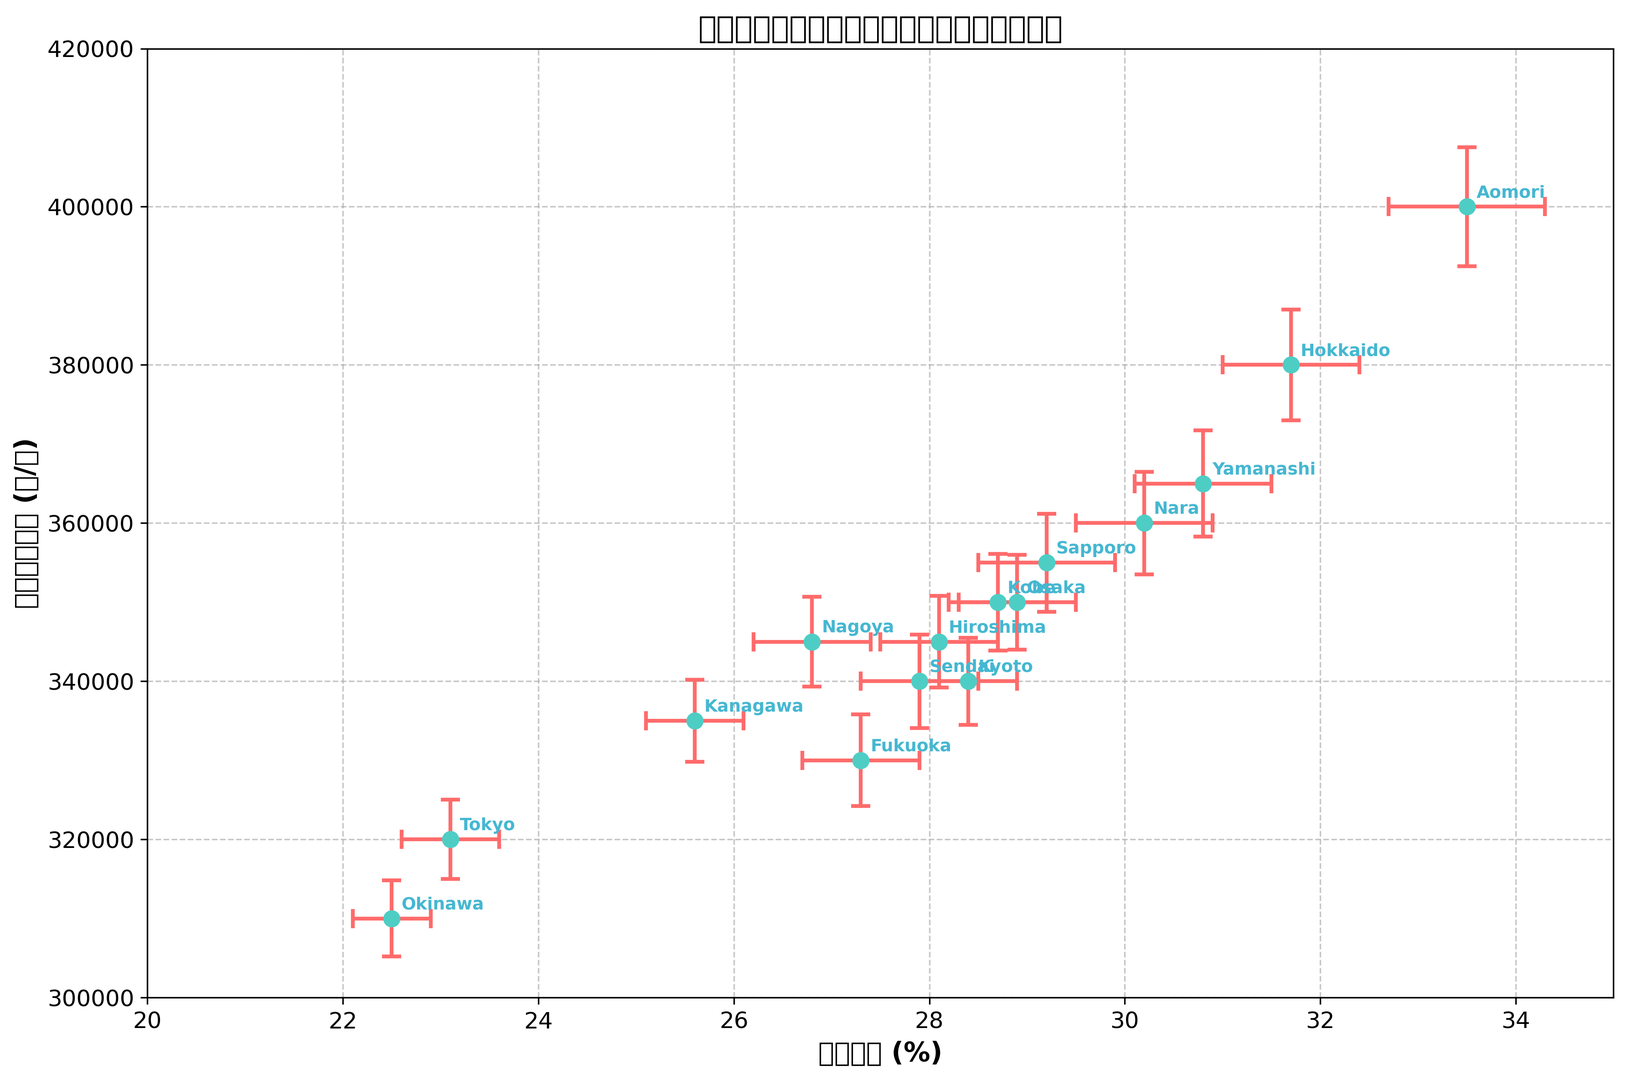Which region has the highest elderly population percentage? By looking at the plotted values of elderly population percentages, the highest value is at Aomori, reaching 33.5%.
Answer: Aomori What is the difference in elderly population percentage between Tokyo and Hokkaido? Tokyo has an elderly population percentage of 23.1%, while Hokkaido has 31.7%. The difference is 31.7% - 23.1% = 8.6%.
Answer: 8.6% Which region has the least welfare expenditure per capita? By checking the y-values of welfare expenditures, the smallest value belongs to Okinawa with 310,000 yen per capita.
Answer: Okinawa How does the welfare expenditure of Tokyo compare with Fukuoka? Tokyo has a welfare expenditure per capita of 320,000 yen, whereas Fukuoka has 330,000 yen. Fukuoka's expenditure is higher.
Answer: Fukuoka has higher expenditure What is the average welfare expenditure per capita of Sendai, Kobe, and Hiroshima? Adding the per capita expenditures: 340,000 (Sendai) + 350,000 (Kobe) + 345,000 (Hiroshima) and dividing by 3: (340,000 + 350,000 + 345,000) / 3 = 345,000 yen.
Answer: 345,000 yen Which region has the greatest margin of error in welfare expenditure, and what is its value? Reviewing the error bars, Aomori has the largest welfare expenditure error value of 7,500 yen.
Answer: Aomori, 7,500 yen Is there a region where the elderly population percentage and welfare expenditure per capita are both lower than nationwide trends represented in the chart? The regions below the median values for both elderly population and welfare expenditure (e.g., median values appear to be around 28% and 345,000 yen respectively) include Okinawa.
Answer: Okinawa Which region has a higher elderly population percentage: Kyoto or Nagoya? Kyoto has an elderly population percentage of 28.4%, while Nagoya has 26.8%. Kyoto's percentage is higher.
Answer: Kyoto 